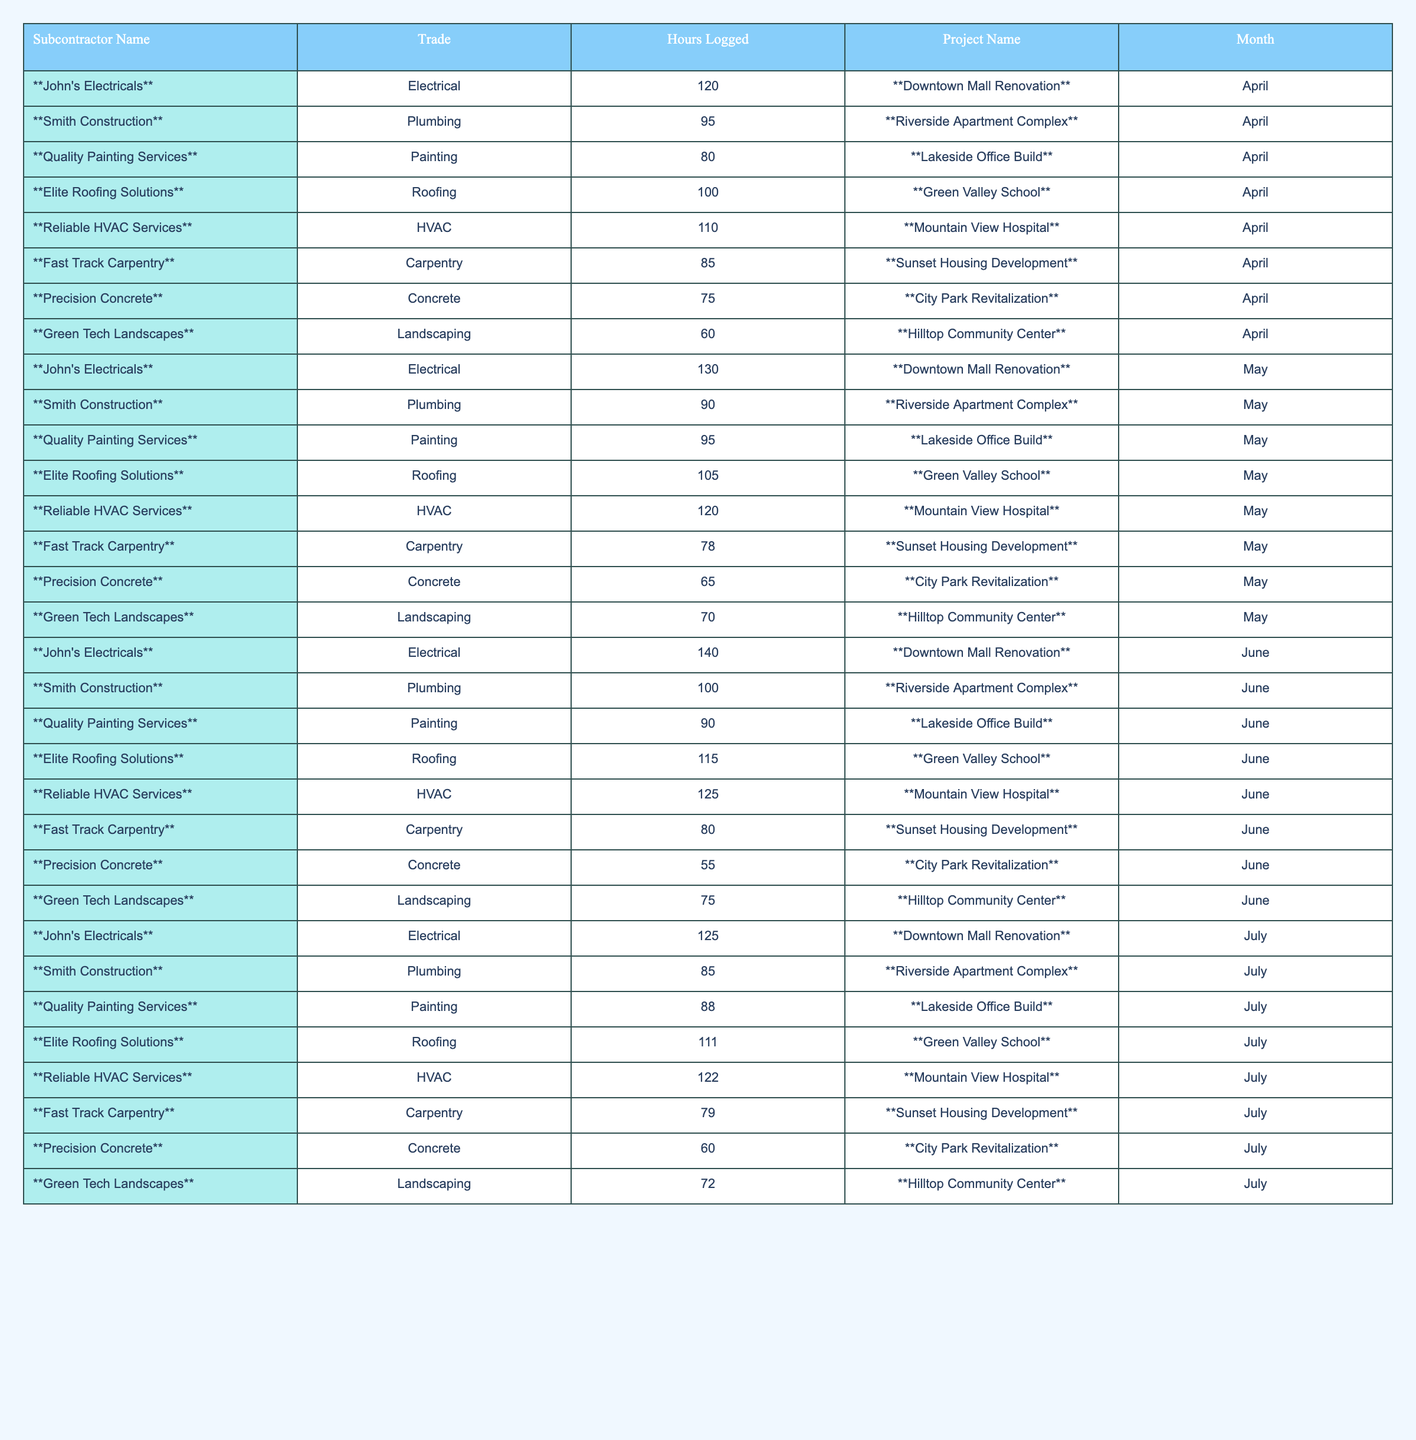What is the total number of hours logged by 'John's Electricals' in the past 6 months? To find the total hours logged by 'John's Electricals', we add the hours from each month: 120 (April) + 130 (May) + 140 (June) + 125 (July) = 515.
Answer: 515 Which subcontractor logged the highest number of hours in June? In June, we check the hours: John's Electricals (140), Smith Construction (100), Quality Painting Services (90), Elite Roofing Solutions (115), Reliable HVAC Services (125), Fast Track Carpentry (80), Precision Concrete (55), and Green Tech Landscapes (75). The highest is 140 by 'John's Electricals'.
Answer: John's Electricals What is the average number of hours logged by 'Reliable HVAC Services'? For 'Reliable HVAC Services', the hours logged are 110 (April), 120 (May), 125 (June), and 122 (July). We sum these: 110 + 120 + 125 + 122 = 477. Then we divide by 4 (months) to get the average: 477 / 4 = 119.25.
Answer: 119.25 Did 'Green Tech Landscapes' log more hours in July compared to June? We compare the hours: 'Green Tech Landscapes' logged 75 hours in June and 72 hours in July. Since 75 > 72, the statement is true.
Answer: Yes What is the total number of logged hours for all subcontractors in May? We look at the hours logged in May: 130 + 90 + 95 + 105 + 120 + 78 + 65 + 70 = 853. This is the total for all subcontractors in that month.
Answer: 853 Which trade had the least amount of total hours logged over the 6 months? We calculate the total hours for each trade: Electrical (515), Plumbing (370), Painting (353), Roofing (431), HVAC (477), Carpentry (322), Concrete (305), Landscaping (432). The least is for Concrete, totaling 305 hours.
Answer: Concrete How many hours did 'Fast Track Carpentry' log in total over the 6 months? For 'Fast Track Carpentry', the monthly hours are: 85 (April) + 78 (May) + 80 (June) + 79 (July). Adding these gives: 85 + 78 + 80 + 79 = 322.
Answer: 322 Which subcontractor had a consistent increase in hours logged for the months provided? To check for consistency in increase: John's Electricals logs: 120, 130, 140, 125 (not consistent); Smith Construction logs: 95, 90, 100, 85 (not consistent); Quality Painting: 80, 95, 90, 88 (not consistent); others similarly do not show consistent increase. No subcontractor demonstrates consistent increase across all months.
Answer: None What was the month with the highest total hours logged across all subcontractors? We calculate the total for each month: April (120 + 95 + 80 + 100 + 110 + 85 + 75 + 60 = 825), May (130 + 90 + 95 + 105 + 120 + 78 + 65 + 70 = 853), June (140 + 100 + 90 + 115 + 125 + 80 + 55 + 75 = 800), July (125 + 85 + 88 + 111 + 122 + 79 + 60 + 72 = 842). The highest is in May with 853 hours.
Answer: May What is the total hours logged by subcontractors in the Plumbing trade? The hours for the Plumbing trade are: 95 (April), 90 (May), 100 (June), 85 (July). Adding these gives: 95 + 90 + 100 + 85 = 370.
Answer: 370 